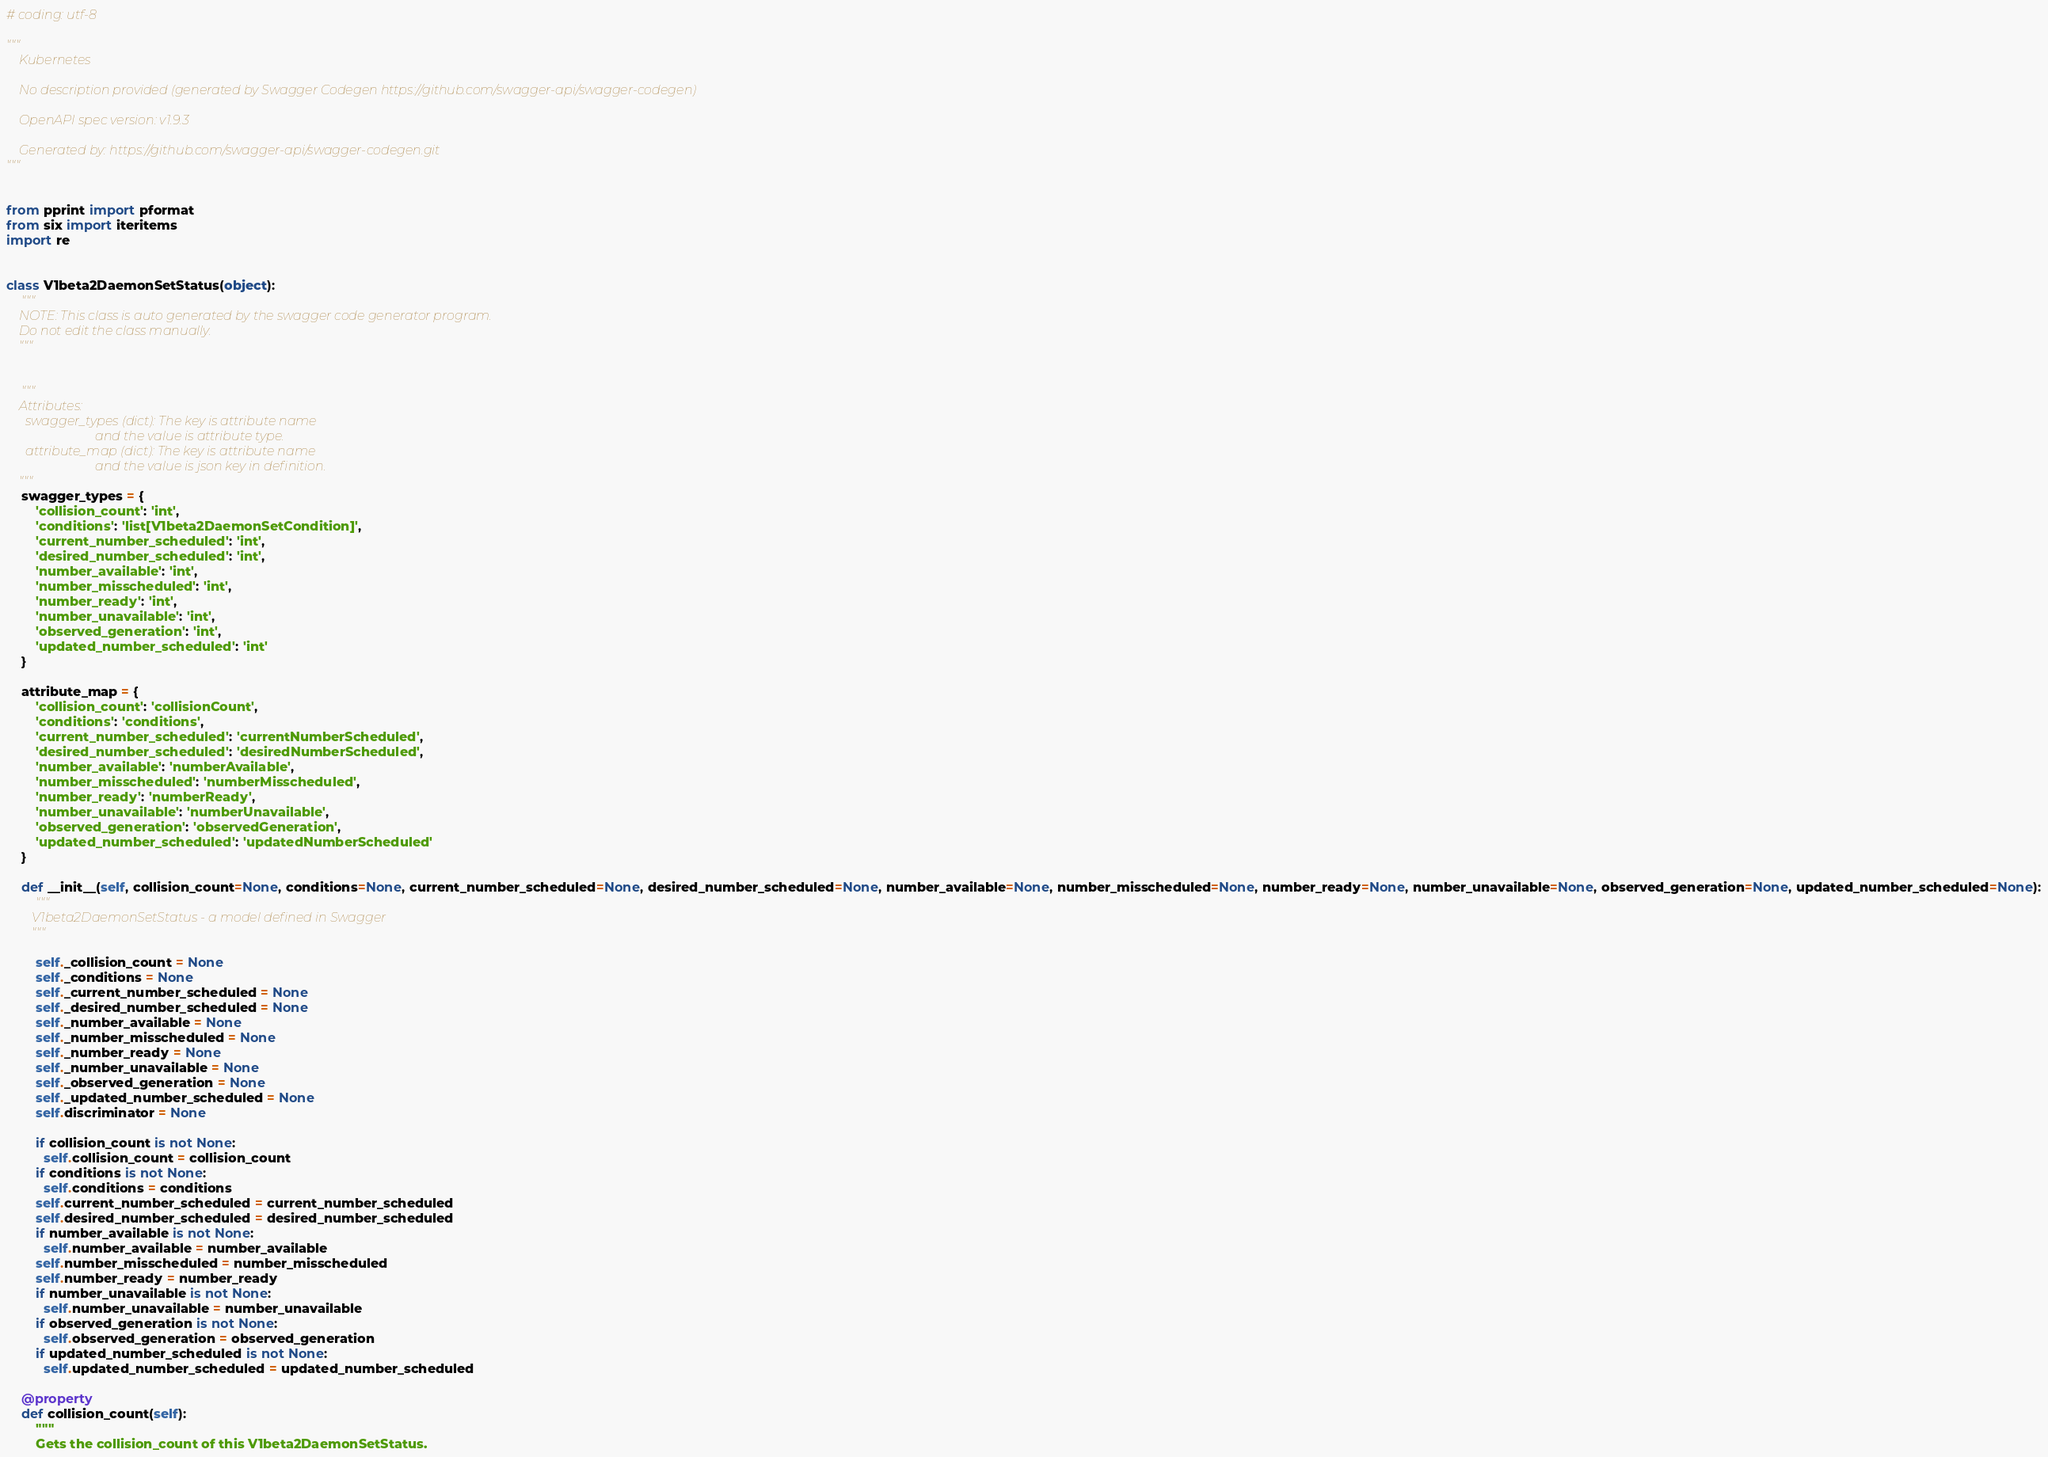<code> <loc_0><loc_0><loc_500><loc_500><_Python_># coding: utf-8

"""
    Kubernetes

    No description provided (generated by Swagger Codegen https://github.com/swagger-api/swagger-codegen)

    OpenAPI spec version: v1.9.3
    
    Generated by: https://github.com/swagger-api/swagger-codegen.git
"""


from pprint import pformat
from six import iteritems
import re


class V1beta2DaemonSetStatus(object):
    """
    NOTE: This class is auto generated by the swagger code generator program.
    Do not edit the class manually.
    """


    """
    Attributes:
      swagger_types (dict): The key is attribute name
                            and the value is attribute type.
      attribute_map (dict): The key is attribute name
                            and the value is json key in definition.
    """
    swagger_types = {
        'collision_count': 'int',
        'conditions': 'list[V1beta2DaemonSetCondition]',
        'current_number_scheduled': 'int',
        'desired_number_scheduled': 'int',
        'number_available': 'int',
        'number_misscheduled': 'int',
        'number_ready': 'int',
        'number_unavailable': 'int',
        'observed_generation': 'int',
        'updated_number_scheduled': 'int'
    }

    attribute_map = {
        'collision_count': 'collisionCount',
        'conditions': 'conditions',
        'current_number_scheduled': 'currentNumberScheduled',
        'desired_number_scheduled': 'desiredNumberScheduled',
        'number_available': 'numberAvailable',
        'number_misscheduled': 'numberMisscheduled',
        'number_ready': 'numberReady',
        'number_unavailable': 'numberUnavailable',
        'observed_generation': 'observedGeneration',
        'updated_number_scheduled': 'updatedNumberScheduled'
    }

    def __init__(self, collision_count=None, conditions=None, current_number_scheduled=None, desired_number_scheduled=None, number_available=None, number_misscheduled=None, number_ready=None, number_unavailable=None, observed_generation=None, updated_number_scheduled=None):
        """
        V1beta2DaemonSetStatus - a model defined in Swagger
        """

        self._collision_count = None
        self._conditions = None
        self._current_number_scheduled = None
        self._desired_number_scheduled = None
        self._number_available = None
        self._number_misscheduled = None
        self._number_ready = None
        self._number_unavailable = None
        self._observed_generation = None
        self._updated_number_scheduled = None
        self.discriminator = None

        if collision_count is not None:
          self.collision_count = collision_count
        if conditions is not None:
          self.conditions = conditions
        self.current_number_scheduled = current_number_scheduled
        self.desired_number_scheduled = desired_number_scheduled
        if number_available is not None:
          self.number_available = number_available
        self.number_misscheduled = number_misscheduled
        self.number_ready = number_ready
        if number_unavailable is not None:
          self.number_unavailable = number_unavailable
        if observed_generation is not None:
          self.observed_generation = observed_generation
        if updated_number_scheduled is not None:
          self.updated_number_scheduled = updated_number_scheduled

    @property
    def collision_count(self):
        """
        Gets the collision_count of this V1beta2DaemonSetStatus.</code> 